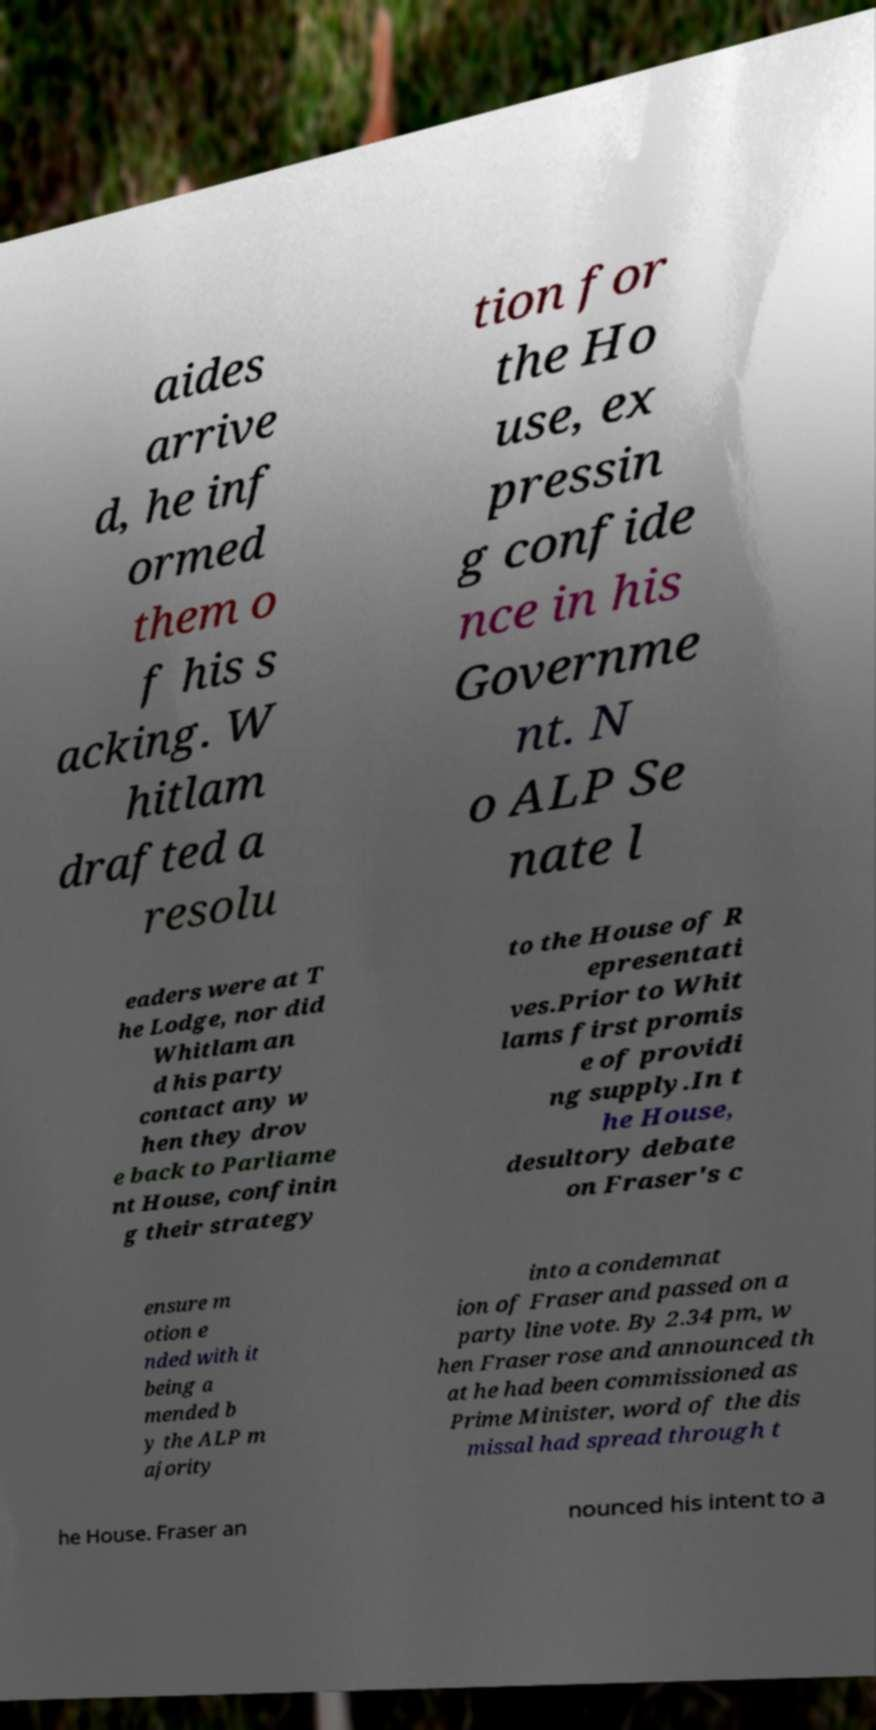Can you read and provide the text displayed in the image?This photo seems to have some interesting text. Can you extract and type it out for me? aides arrive d, he inf ormed them o f his s acking. W hitlam drafted a resolu tion for the Ho use, ex pressin g confide nce in his Governme nt. N o ALP Se nate l eaders were at T he Lodge, nor did Whitlam an d his party contact any w hen they drov e back to Parliame nt House, confinin g their strategy to the House of R epresentati ves.Prior to Whit lams first promis e of providi ng supply.In t he House, desultory debate on Fraser's c ensure m otion e nded with it being a mended b y the ALP m ajority into a condemnat ion of Fraser and passed on a party line vote. By 2.34 pm, w hen Fraser rose and announced th at he had been commissioned as Prime Minister, word of the dis missal had spread through t he House. Fraser an nounced his intent to a 